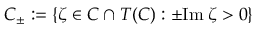<formula> <loc_0><loc_0><loc_500><loc_500>C _ { \pm } \colon = \{ \zeta \in C \cap T ( C ) \colon \pm I m \, \zeta > 0 \}</formula> 